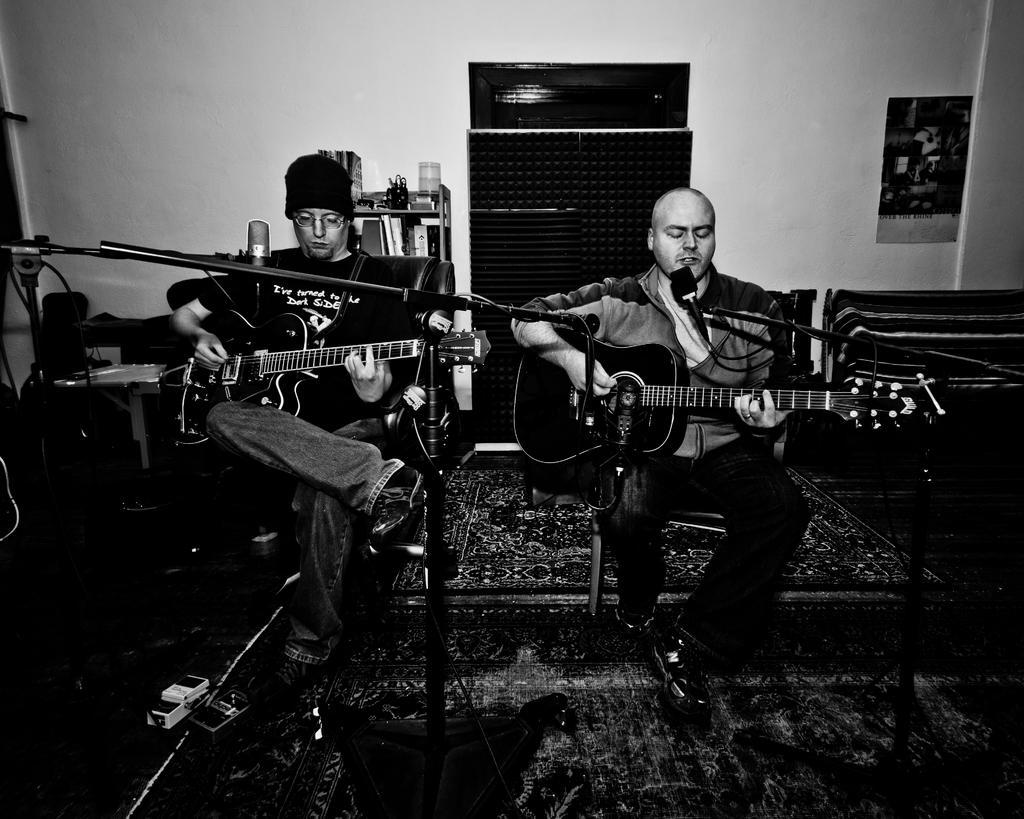How would you summarize this image in a sentence or two? This is a black and white picture. There is a wall on the background and its a calendar. On the desk we can see glass , books. Here we can see two persons sitting on chairs in front of a mike and playing guitar. This is a floor carpet. This is an adapter. 